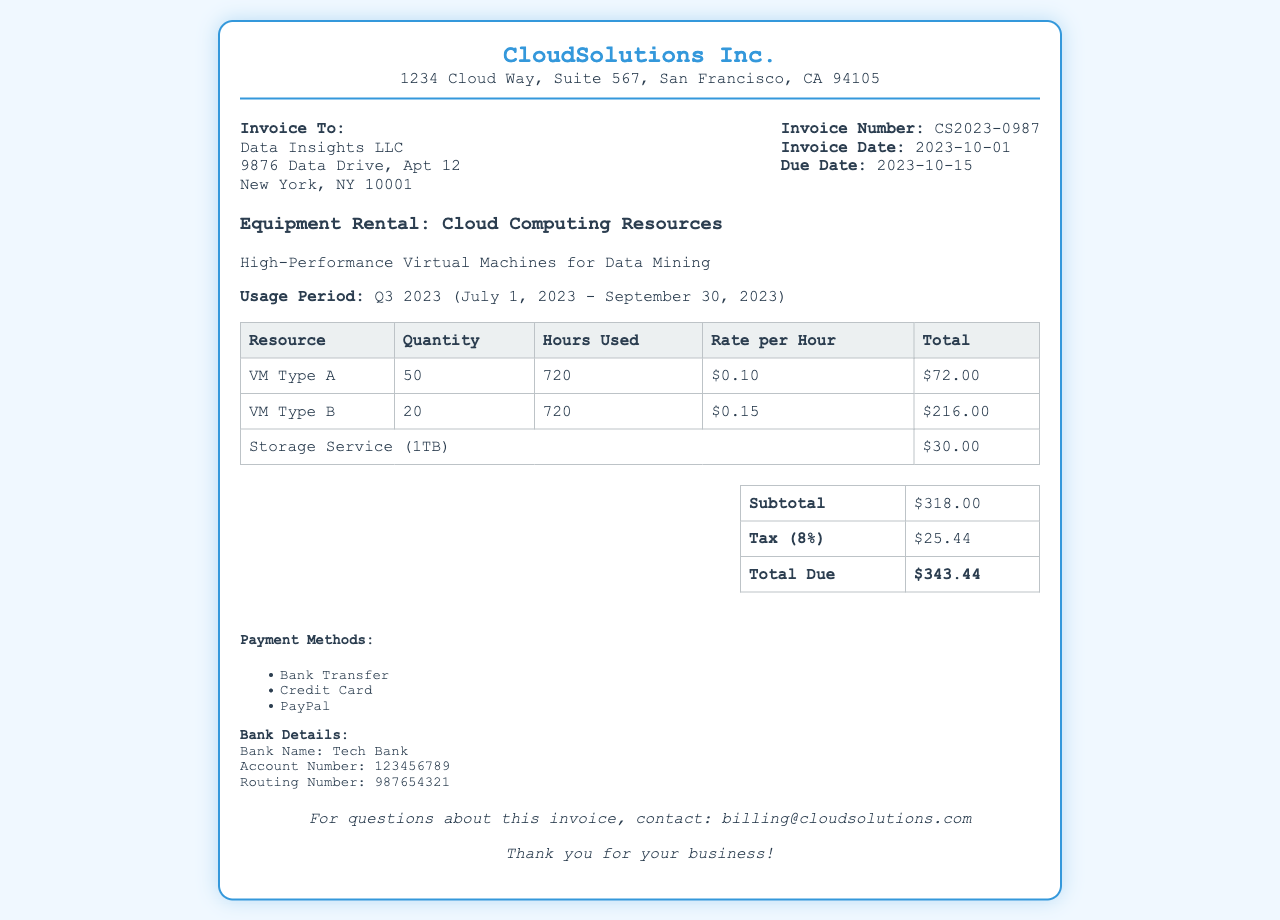What is the invoice number? The invoice number is uniquely assigned to identify this invoice, which is mentioned in the document.
Answer: CS2023-0987 What is the due date? The due date is the last date by which the payment should be made, which is provided in the invoice details.
Answer: 2023-10-15 How many hours were VM Type A used? The document specifies the number of hours VM Type A was utilized for the data mining activities.
Answer: 720 What is the subtotal amount? The subtotal amount is the sum of all charges before tax, detailed in the summary table.
Answer: $318.00 What percentage is the tax applied? The tax percentage is mentioned in the summary table, indicating the tax rate applied to the subtotal.
Answer: 8% What is the total amount due? The total amount due is calculated by adding the subtotal and the tax, as shown in the summary section.
Answer: $343.44 What is the payment method option? The invoice lists different options available for making the payment, indicating flexibility for the payer.
Answer: Bank Transfer What is the storage service charge? The charge for the storage service is specifically mentioned in the usage details for clarity on costs.
Answer: $30.00 What is the address of CloudSolutions Inc.? The address of CloudSolutions Inc. is provided at the top of the invoice for reference and contact.
Answer: 1234 Cloud Way, Suite 567, San Francisco, CA 94105 